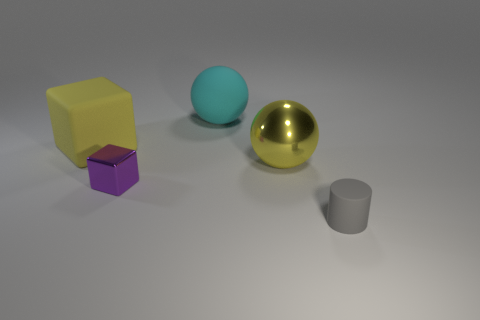Is the shape of the big shiny thing the same as the yellow rubber thing?
Keep it short and to the point. No. The yellow object that is the same shape as the purple shiny thing is what size?
Ensure brevity in your answer.  Large. The big shiny thing that is the same shape as the big cyan matte object is what color?
Make the answer very short. Yellow. How big is the matte thing that is both behind the tiny cylinder and on the right side of the tiny cube?
Keep it short and to the point. Large. There is a big yellow metallic object that is behind the small object that is left of the tiny gray matte thing; how many large yellow things are behind it?
Provide a short and direct response. 1. How many small objects are yellow metallic spheres or brown shiny cylinders?
Ensure brevity in your answer.  0. Is the material of the large yellow object on the left side of the big yellow sphere the same as the purple cube?
Provide a short and direct response. No. There is a sphere that is on the left side of the metal thing behind the tiny thing that is behind the small matte cylinder; what is it made of?
Your response must be concise. Rubber. Are there any other things that have the same size as the yellow rubber thing?
Offer a very short reply. Yes. What number of shiny things are either tiny gray cubes or small purple things?
Offer a terse response. 1. 